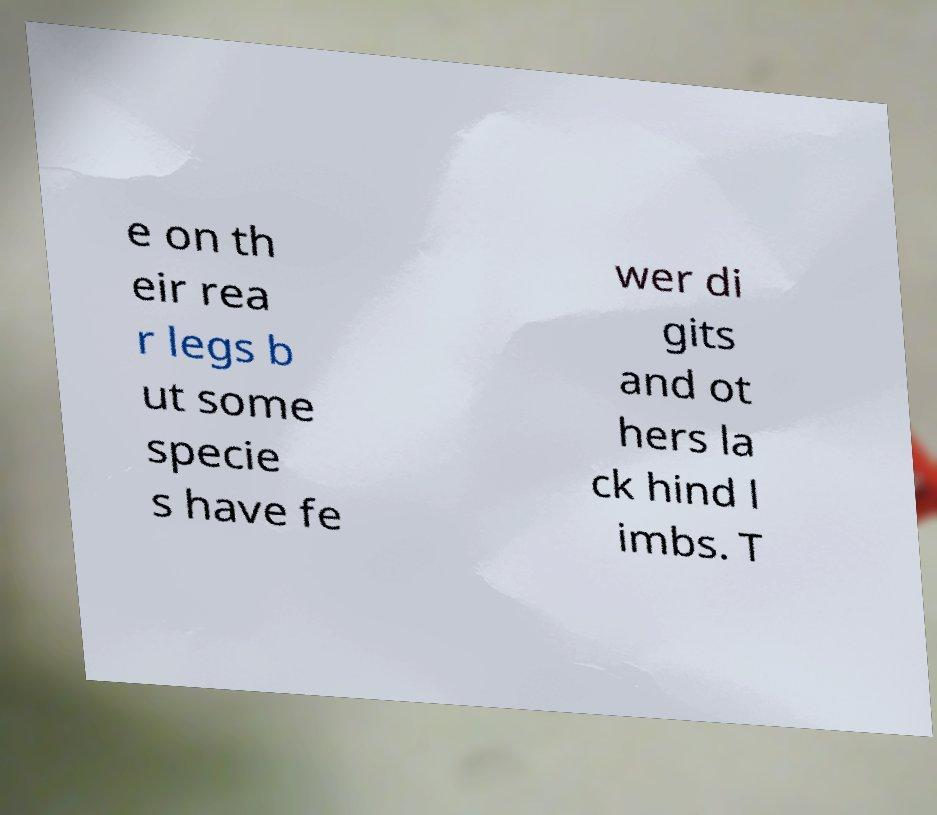There's text embedded in this image that I need extracted. Can you transcribe it verbatim? e on th eir rea r legs b ut some specie s have fe wer di gits and ot hers la ck hind l imbs. T 